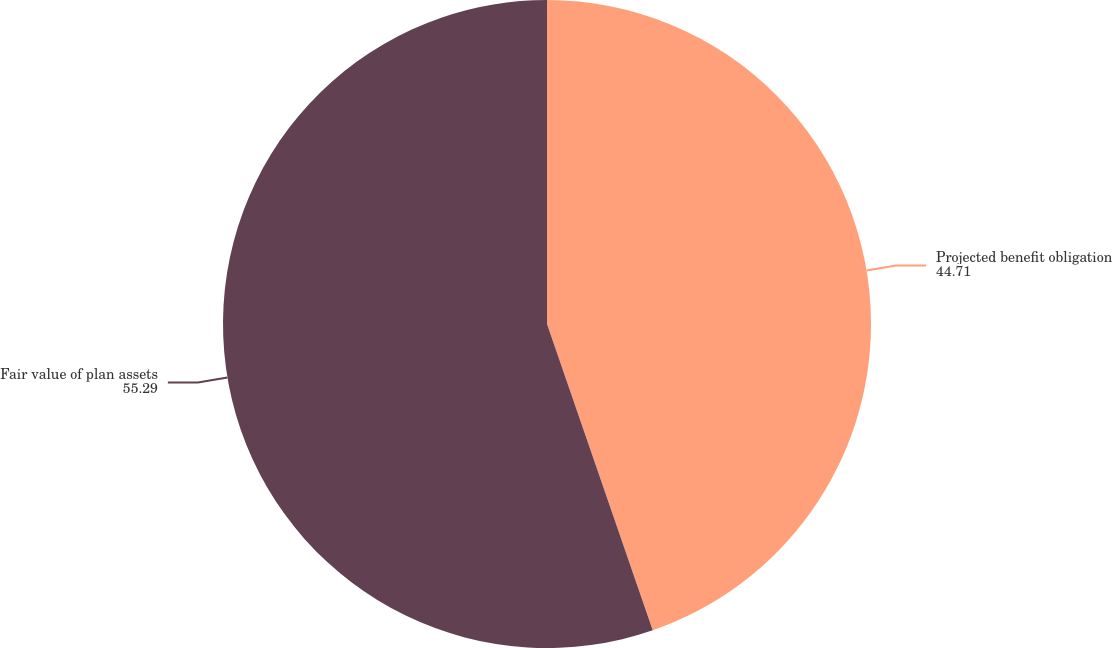<chart> <loc_0><loc_0><loc_500><loc_500><pie_chart><fcel>Projected benefit obligation<fcel>Fair value of plan assets<nl><fcel>44.71%<fcel>55.29%<nl></chart> 